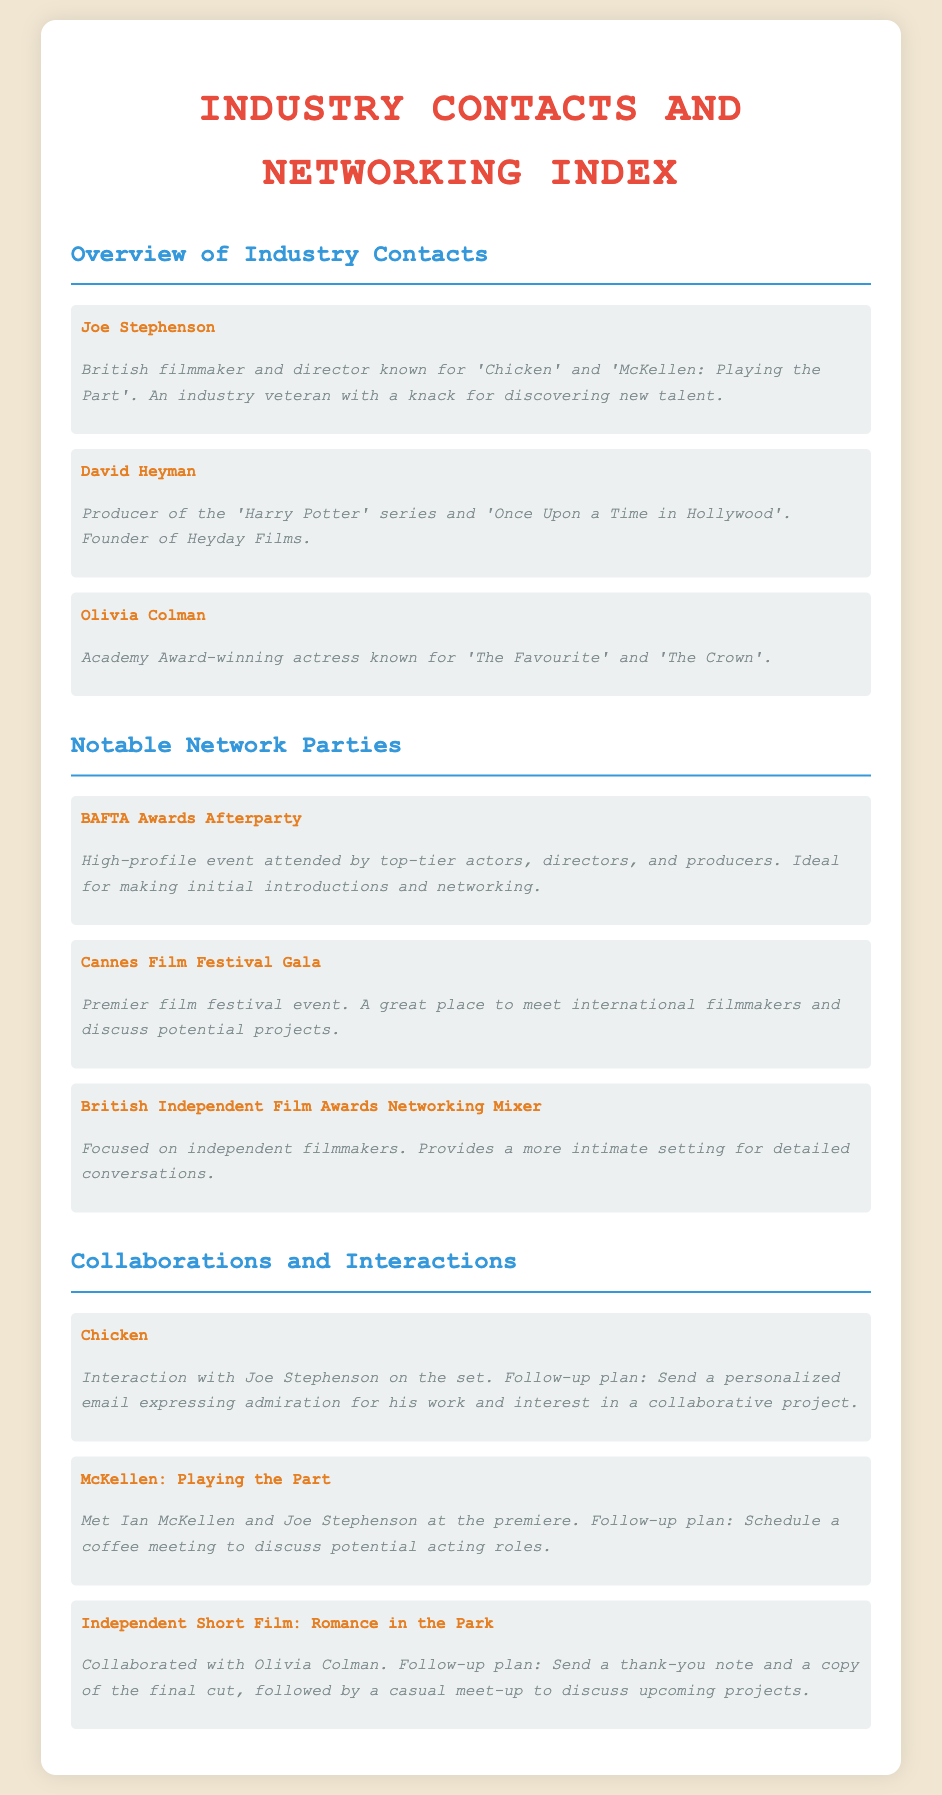what is Joe Stephenson known for? Joe Stephenson is known for being a British filmmaker and director known for 'Chicken' and 'McKellen: Playing the Part'.
Answer: 'Chicken' and 'McKellen: Playing the Part' who produced the Harry Potter series? The document states that David Heyman produced the 'Harry Potter' series.
Answer: David Heyman which event is ideal for making initial introductions? The BAFTA Awards Afterparty is described as the ideal event for making initial introductions.
Answer: BAFTA Awards Afterparty what is the follow-up plan after interacting with Joe Stephenson on the set of Chicken? The follow-up plan is to send a personalized email expressing admiration for his work and interest in a collaborative project.
Answer: Send a personalized email name one collaboration with Olivia Colman. The document mentions collaboration with Olivia Colman in the independent short film titled 'Romance in the Park'.
Answer: Romance in the Park which networking event focuses on independent filmmakers? The British Independent Film Awards Networking Mixer is focused on independent filmmakers.
Answer: British Independent Film Awards Networking Mixer how many notable industry contacts are listed in the document? There are three notable industry contacts listed in the document.
Answer: 3 what is the location of the Cannes Film Festival Gala? The document implies it is an international event but does not specify the location; it focuses on meeting international filmmakers.
Answer: Not specified 